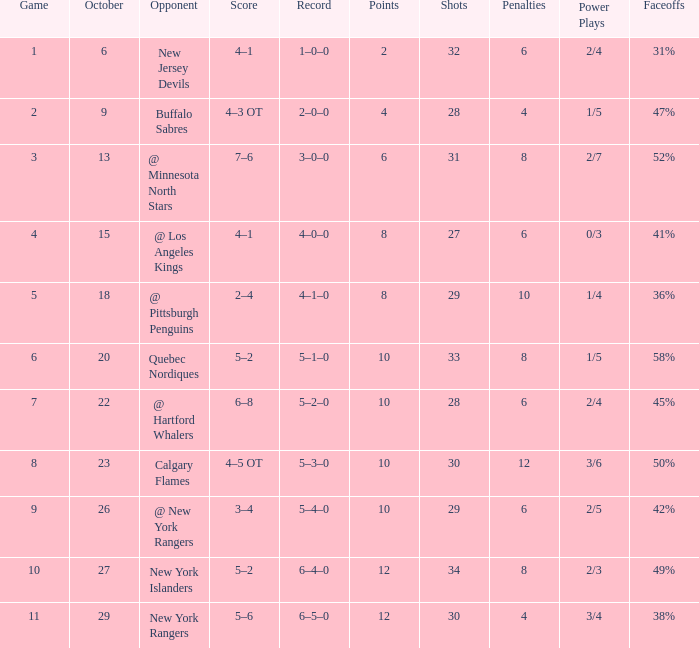How many Points have an Opponent of @ los angeles kings and a Game larger than 4? None. 